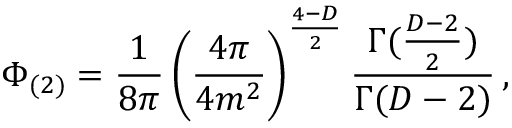Convert formula to latex. <formula><loc_0><loc_0><loc_500><loc_500>\Phi _ { ( 2 ) } = \frac { 1 } { 8 \pi } \left ( \frac { 4 \pi } { 4 m ^ { 2 } } \right ) ^ { \frac { 4 - D } { 2 } } \frac { \Gamma ( { \frac { D - 2 } { 2 } } ) } { \Gamma ( D - 2 ) } \, ,</formula> 